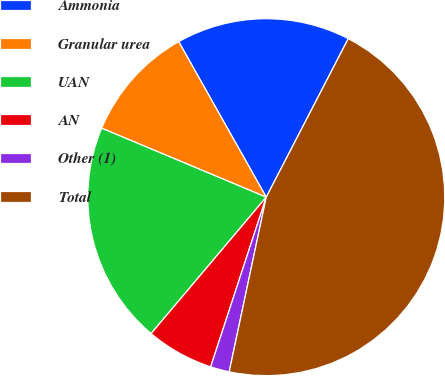<chart> <loc_0><loc_0><loc_500><loc_500><pie_chart><fcel>Ammonia<fcel>Granular urea<fcel>UAN<fcel>AN<fcel>Other (1)<fcel>Total<nl><fcel>15.76%<fcel>10.52%<fcel>20.16%<fcel>6.12%<fcel>1.71%<fcel>45.73%<nl></chart> 